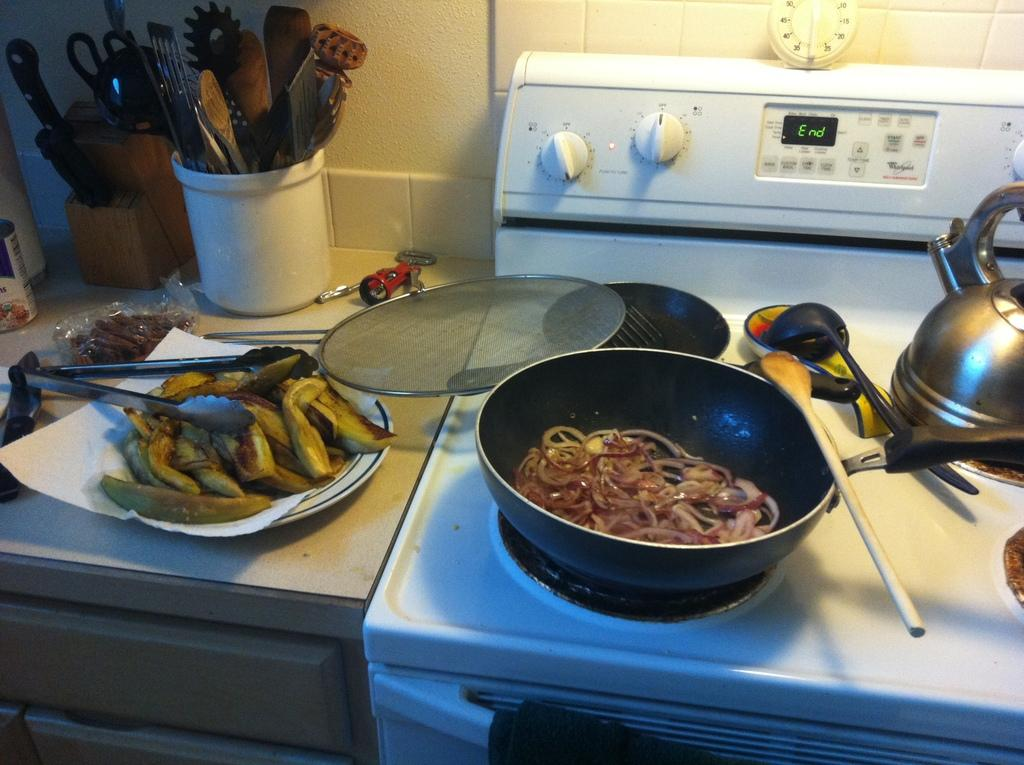<image>
Summarize the visual content of the image. The display of a white oven reads "End," with a pan of food on top of it. 